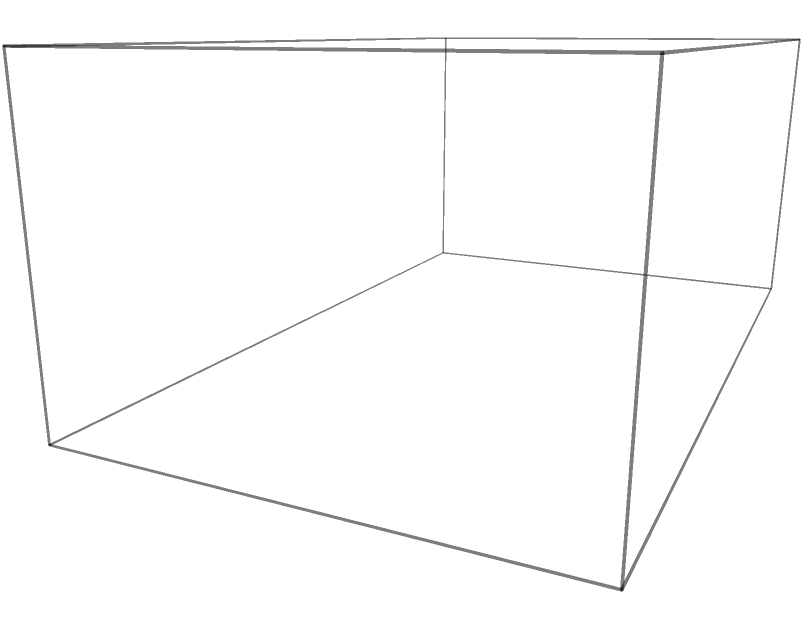As a rival car reviewer, you're examining a high-performance V8 engine block. The block measures 10 cm x 6 cm x 4 cm and contains 8 cylindrical chambers, each with a diameter of 2 cm and a height of 4 cm. What is the total volume of metal in the engine block, excluding the cylindrical chambers? Express your answer in cubic centimeters (cm³). To find the volume of metal in the engine block, we need to:

1. Calculate the total volume of the engine block:
   $V_{block} = 10 \text{ cm} \times 6 \text{ cm} \times 4 \text{ cm} = 240 \text{ cm}^3$

2. Calculate the volume of one cylindrical chamber:
   $V_{cylinder} = \pi r^2 h = \pi \times (1 \text{ cm})^2 \times 4 \text{ cm} = 4\pi \text{ cm}^3$

3. Calculate the total volume of all 8 cylindrical chambers:
   $V_{total cylinders} = 8 \times 4\pi \text{ cm}^3 = 32\pi \text{ cm}^3$

4. Subtract the volume of the cylinders from the total block volume:
   $V_{metal} = V_{block} - V_{total cylinders}$
   $V_{metal} = 240 \text{ cm}^3 - 32\pi \text{ cm}^3$
   $V_{metal} = 240 - 100.53 \text{ cm}^3$ (rounded to 2 decimal places)
   $V_{metal} = 139.47 \text{ cm}^3$

Therefore, the volume of metal in the engine block is approximately 139.47 cm³.
Answer: 139.47 cm³ 